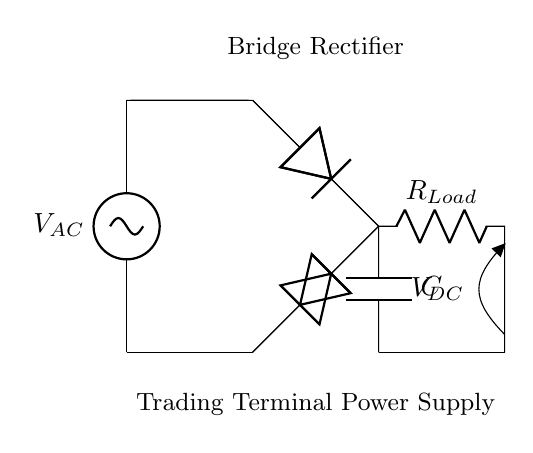What type of rectifier is shown in the circuit? The circuit represents a bridge rectifier, identified by the arrangement of four diodes in a bridge configuration.
Answer: bridge rectifier What component converts AC to DC? The component responsible for the conversion of AC to DC in this circuit is the bridge rectifier, which aligns the AC current flow, allowing a unidirectional output.
Answer: bridge rectifier How many diodes are used in this circuit? There are four diodes in a bridge rectifier configuration, which work together to allow current to flow in one direction during both halves of the AC cycle.
Answer: four What is the purpose of the capacitor in this circuit? The capacitor smooths the output voltage by storing charge and releasing it when the voltage drops, reducing the ripple in the DC output.
Answer: smoothing What is the load resistor labeled in the circuit? The load resistor, indicated as R_Load, represents the component where the DC output is utilized, converting electrical energy to perform work.
Answer: R_Load What is the DC output voltage indicated in the diagram? While the diagram doesn't specify an exact voltage value, the DC output voltage (V_DC) is referenced, showing the potential difference after rectification.
Answer: V_DC What is the main effect of using a bridge rectifier compared to a half-wave rectifier? The main advantage of a bridge rectifier over a half-wave rectifier is that it utilizes both halves of the AC cycle, resulting in higher efficiency and a smoother DC output.
Answer: higher efficiency 